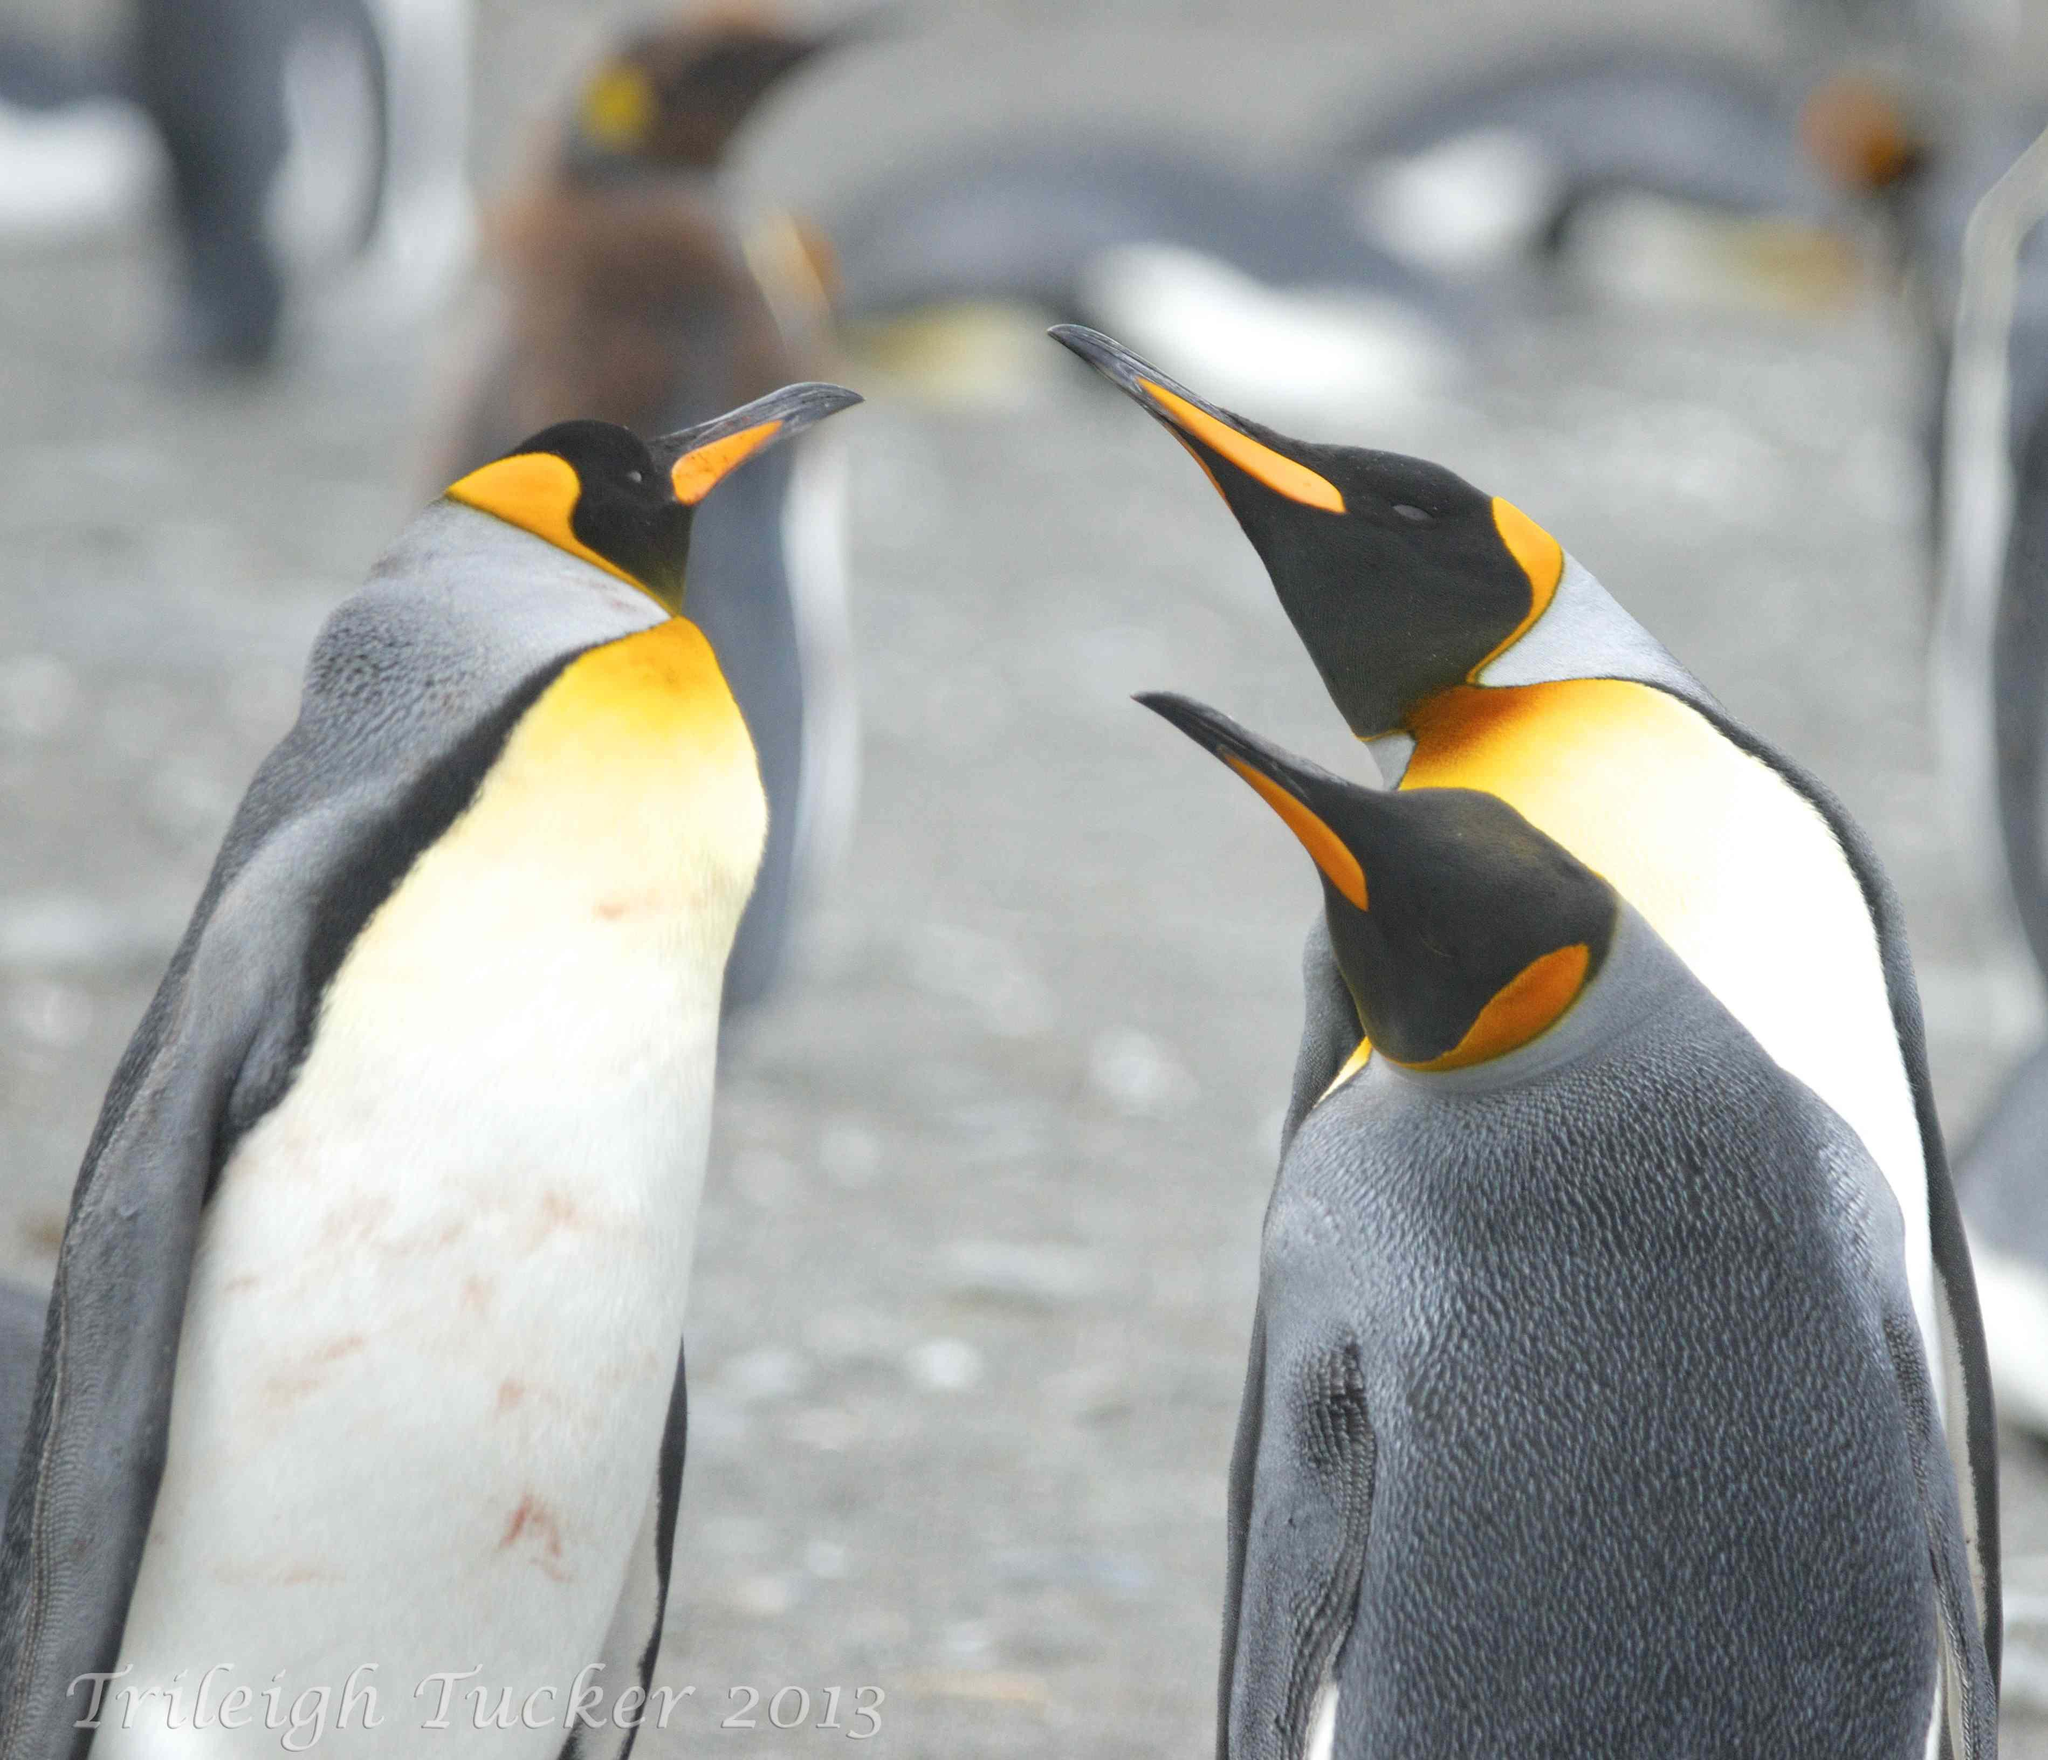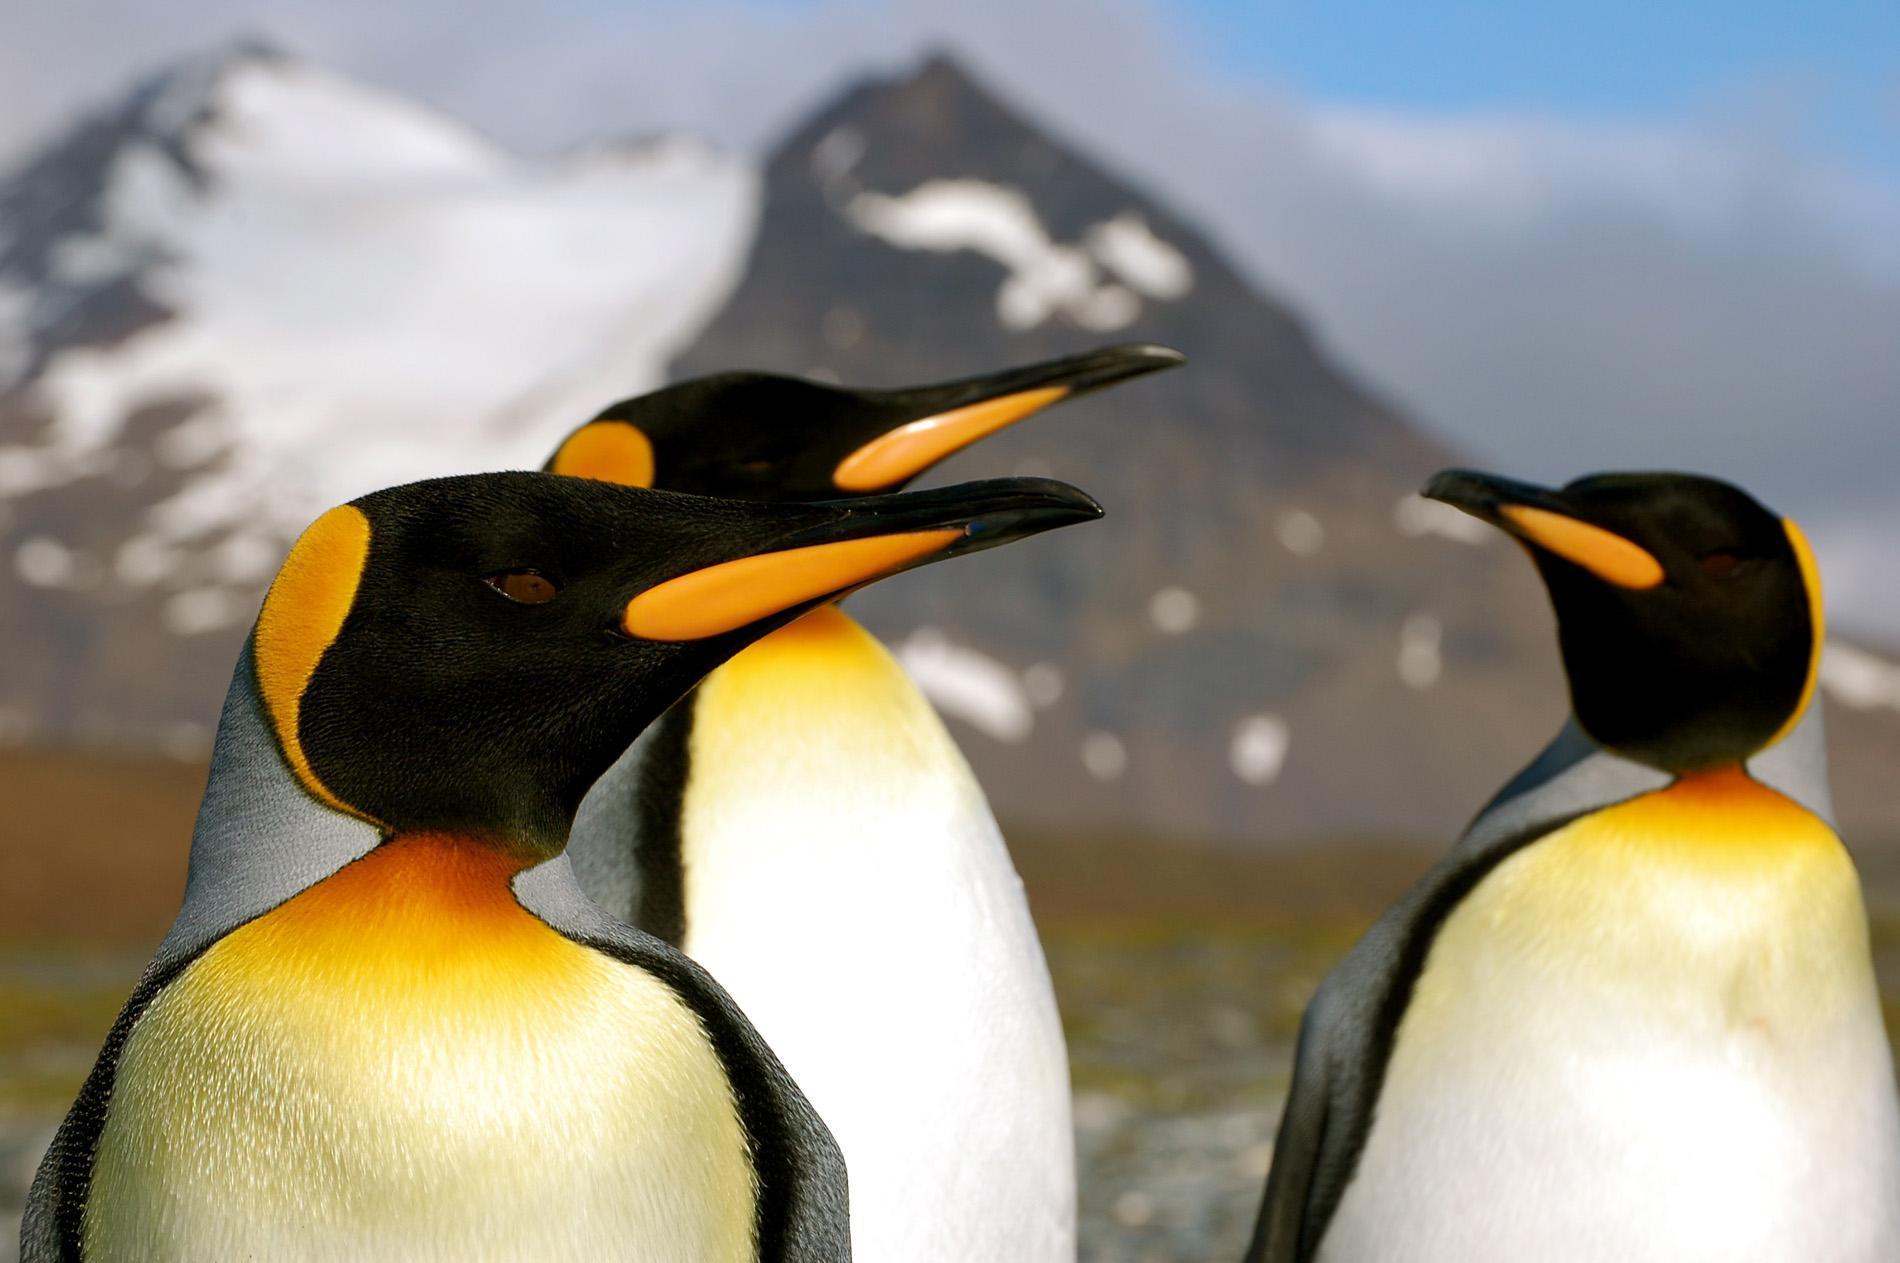The first image is the image on the left, the second image is the image on the right. Assess this claim about the two images: "In one image there is a pair of penguins nuzzling each others' beak.". Correct or not? Answer yes or no. No. 